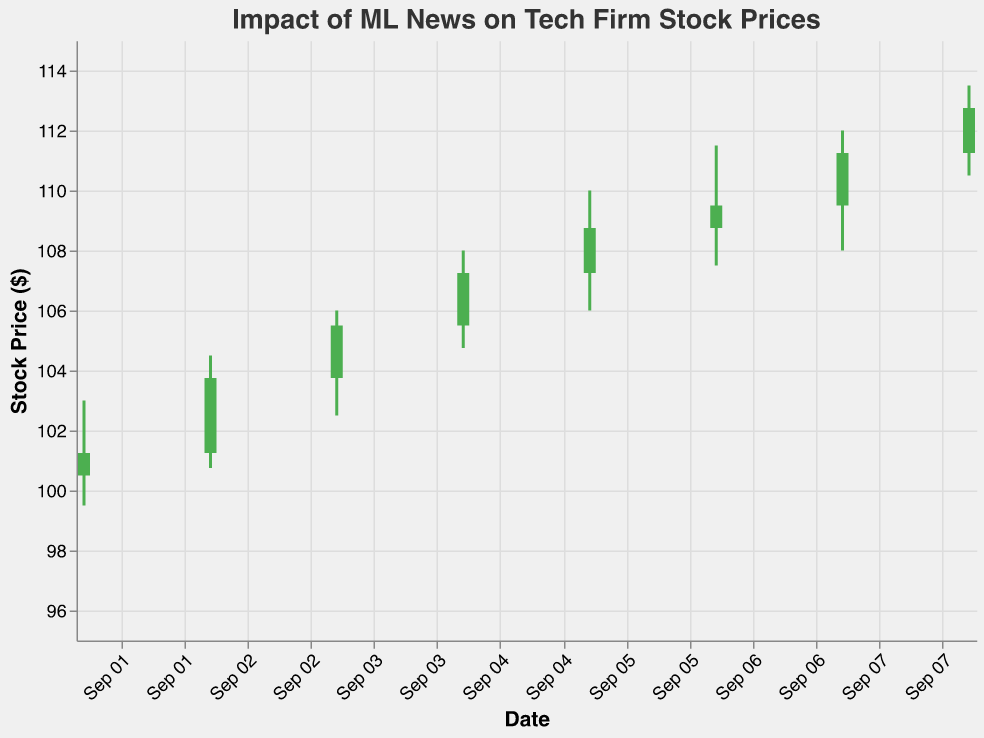What is the title of the figure? The title is displayed prominently at the top of the figure. It reads "Impact of ML News on Tech Firm Stock Prices".
Answer: Impact of ML News on Tech Firm Stock Prices How did the stock price close on September 5th? The candlestick for September 5th has marks that show the opening, closing, high, and low prices of the stock. The closing price for September 5th is marked as 108.75.
Answer: 108.75 Which day had the highest closing stock price? By examining the "Close" values within each candlestick, the highest closing stock price is 112.75, which occurred on September 8th.
Answer: September 8th Compare the stock price increase between September 1st and September 2nd. On September 1st, the closing price was 101.25. On September 2nd, the closing price was 103.75. The increase is calculated as 103.75 - 101.25 = 2.50.
Answer: 2.50 What news event occurred on the day with the lowest stock price, and what was that price? The lowest stock price can be identified by looking at the "Low" values across candlesticks. The lowest price is 99.50 on September 1st. The news event was "Google releases new AI framework with improved NLP capabilities".
Answer: Google releases new AI framework with improved NLP capabilities, 99.50 On which day did the stock experience the largest difference between its high and low prices? The difference between high and low prices for each day can be computed. The largest difference is on September 7th with values 112.00 - 108.00 = 4.00.
Answer: September 7th What was the trend in stock price from September 6th to September 8th? Observing the closing prices from September 6th (109.50), September 7th (111.25), and September 8th (112.75), the trend shows a consistent increase in the stock price.
Answer: Increasing What is the average closing price over the given period? To calculate the average, sum the closing prices (101.25 + 103.75 + 105.50 + 107.25 + 108.75 + 109.50 + 111.25 + 112.75) and divide by the number of days (8). The total sum is 859.00, and the average is 859.00 / 8 = 107.38.
Answer: 107.38 Which day had the lowest volume of trading, and what was the volume? The volumes are displayed for each date. The lowest volume of trading occurred on September 1st with a volume of 1,500,000.
Answer: September 1st, 1,500,000 